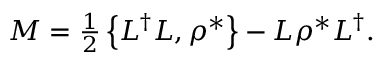<formula> <loc_0><loc_0><loc_500><loc_500>\begin{array} { r } { M = \frac { 1 } { 2 } \left \{ L ^ { \dag } L , \rho ^ { * } \right \} - L \rho ^ { * } L ^ { \dag } . } \end{array}</formula> 